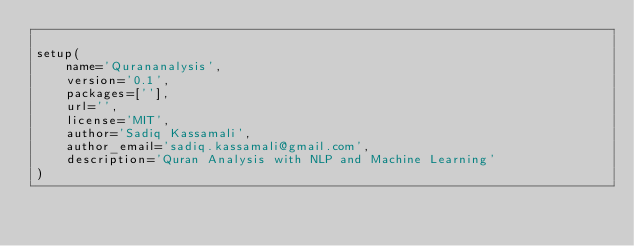Convert code to text. <code><loc_0><loc_0><loc_500><loc_500><_Python_>
setup(
    name='Qurananalysis',
    version='0.1',
    packages=[''],
    url='',
    license='MIT',
    author='Sadiq Kassamali',
    author_email='sadiq.kassamali@gmail.com',
    description='Quran Analysis with NLP and Machine Learning'
)
</code> 